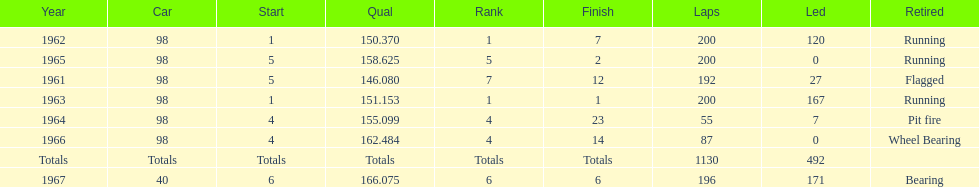Could you parse the entire table as a dict? {'header': ['Year', 'Car', 'Start', 'Qual', 'Rank', 'Finish', 'Laps', 'Led', 'Retired'], 'rows': [['1962', '98', '1', '150.370', '1', '7', '200', '120', 'Running'], ['1965', '98', '5', '158.625', '5', '2', '200', '0', 'Running'], ['1961', '98', '5', '146.080', '7', '12', '192', '27', 'Flagged'], ['1963', '98', '1', '151.153', '1', '1', '200', '167', 'Running'], ['1964', '98', '4', '155.099', '4', '23', '55', '7', 'Pit fire'], ['1966', '98', '4', '162.484', '4', '14', '87', '0', 'Wheel Bearing'], ['Totals', 'Totals', 'Totals', 'Totals', 'Totals', 'Totals', '1130', '492', ''], ['1967', '40', '6', '166.075', '6', '6', '196', '171', 'Bearing']]} What car achieved the highest qual? 40. 